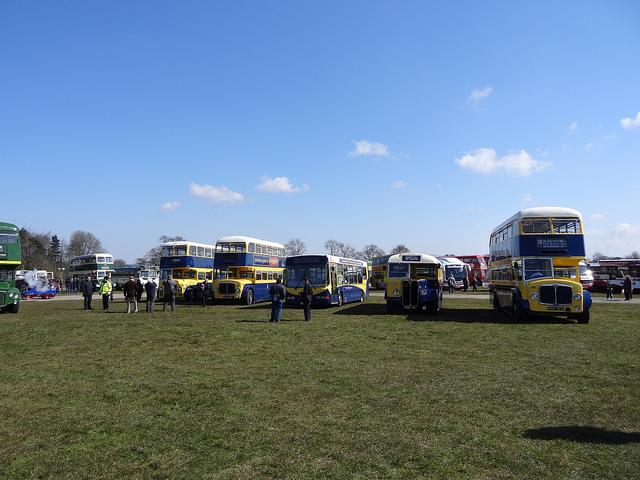How many vehicles?
Answer briefly. 12. How many buses are there?
Be succinct. 6. Is the sky cloudy?
Keep it brief. Yes. Which buses are double deckers?
Keep it brief. 1 on right and 3 on left. Are those taxi cabs in the background?
Give a very brief answer. No. What color is the middle car?
Answer briefly. Yellow and blue. 